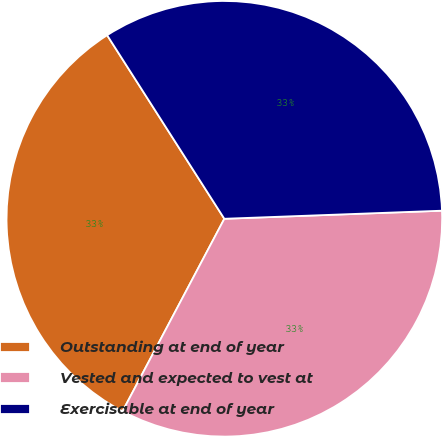Convert chart to OTSL. <chart><loc_0><loc_0><loc_500><loc_500><pie_chart><fcel>Outstanding at end of year<fcel>Vested and expected to vest at<fcel>Exercisable at end of year<nl><fcel>33.21%<fcel>33.33%<fcel>33.45%<nl></chart> 